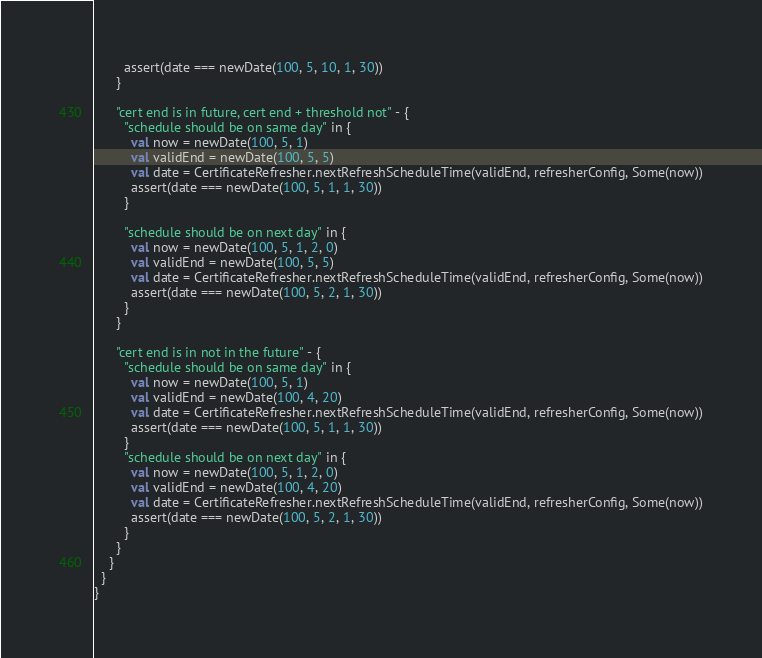Convert code to text. <code><loc_0><loc_0><loc_500><loc_500><_Scala_>        assert(date === newDate(100, 5, 10, 1, 30))
      }

      "cert end is in future, cert end + threshold not" - {
        "schedule should be on same day" in {
          val now = newDate(100, 5, 1)
          val validEnd = newDate(100, 5, 5)
          val date = CertificateRefresher.nextRefreshScheduleTime(validEnd, refresherConfig, Some(now))
          assert(date === newDate(100, 5, 1, 1, 30))
        }

        "schedule should be on next day" in {
          val now = newDate(100, 5, 1, 2, 0)
          val validEnd = newDate(100, 5, 5)
          val date = CertificateRefresher.nextRefreshScheduleTime(validEnd, refresherConfig, Some(now))
          assert(date === newDate(100, 5, 2, 1, 30))
        }
      }

      "cert end is in not in the future" - {
        "schedule should be on same day" in {
          val now = newDate(100, 5, 1)
          val validEnd = newDate(100, 4, 20)
          val date = CertificateRefresher.nextRefreshScheduleTime(validEnd, refresherConfig, Some(now))
          assert(date === newDate(100, 5, 1, 1, 30))
        }
        "schedule should be on next day" in {
          val now = newDate(100, 5, 1, 2, 0)
          val validEnd = newDate(100, 4, 20)
          val date = CertificateRefresher.nextRefreshScheduleTime(validEnd, refresherConfig, Some(now))
          assert(date === newDate(100, 5, 2, 1, 30))
        }
      }
    }
  }
}
</code> 